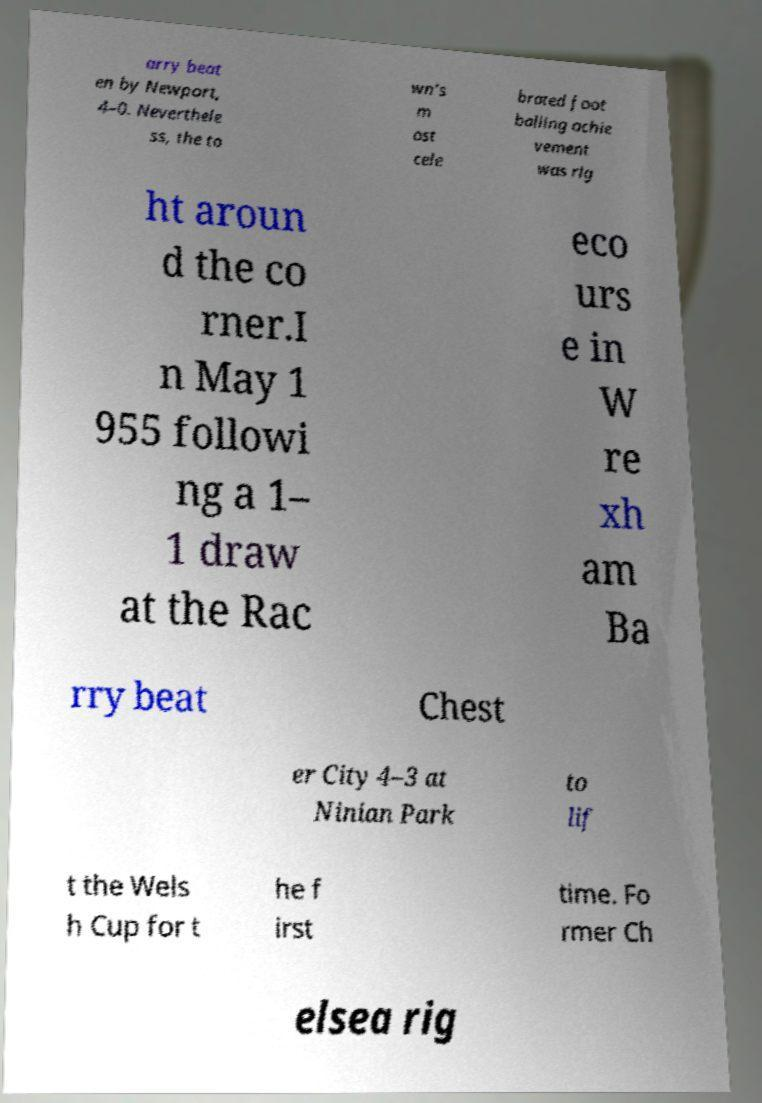Can you accurately transcribe the text from the provided image for me? arry beat en by Newport, 4–0. Neverthele ss, the to wn's m ost cele brated foot balling achie vement was rig ht aroun d the co rner.I n May 1 955 followi ng a 1– 1 draw at the Rac eco urs e in W re xh am Ba rry beat Chest er City 4–3 at Ninian Park to lif t the Wels h Cup for t he f irst time. Fo rmer Ch elsea rig 